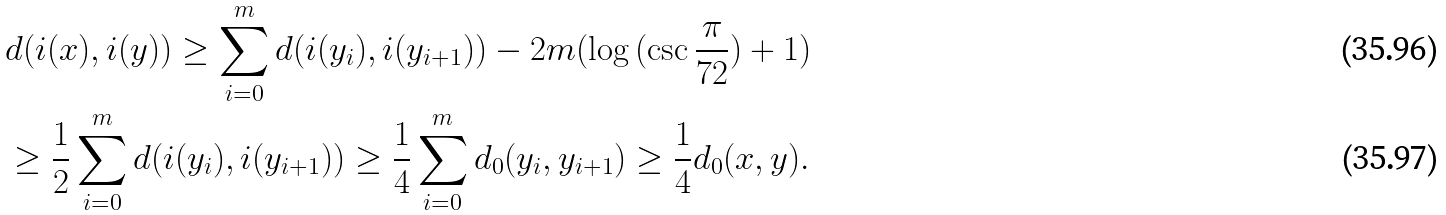<formula> <loc_0><loc_0><loc_500><loc_500>& d ( i ( x ) , i ( y ) ) \geq \sum _ { i = 0 } ^ { m } d ( i ( y _ { i } ) , i ( y _ { i + 1 } ) ) - 2 m ( \log { ( \csc { \frac { \pi } { 7 2 } } ) } + 1 ) \\ & \geq \frac { 1 } { 2 } \sum _ { i = 0 } ^ { m } d ( i ( y _ { i } ) , i ( y _ { i + 1 } ) ) \geq \frac { 1 } { 4 } \sum _ { i = 0 } ^ { m } d _ { 0 } ( y _ { i } , y _ { i + 1 } ) \geq \frac { 1 } { 4 } d _ { 0 } ( x , y ) .</formula> 